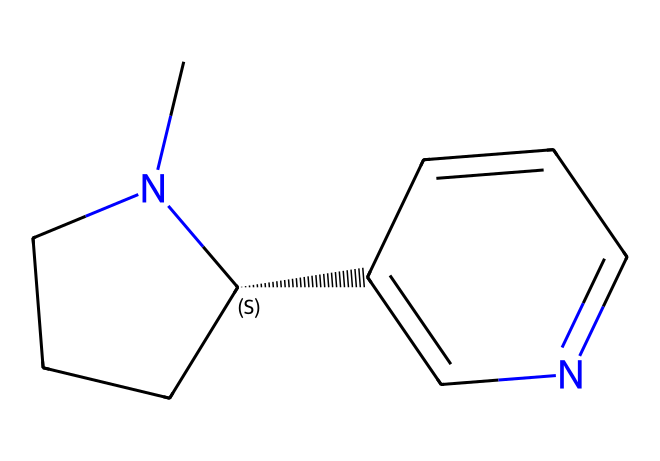What is the molecular formula of nicotine? To determine the molecular formula from the SMILES representation, we need to count the number of each type of atom present in the structure. The provided SMILES indicates there are 10 carbon atoms (C), 14 hydrogen atoms (H), and 2 nitrogen atoms (N). Therefore, the molecular formula is derived from this count.
Answer: C10H14N2 How many rings are present in the structure of nicotine? By analyzing the structure indicated by the SMILES notation, we can identify the presence of cyclic structures. The SMILES shows two distinct ring systems in the molecule. Therefore, we conclude that there are two rings.
Answer: 2 What functional groups can be identified in nicotine? The SMILES structure reveals specific atoms and bonding arrangements that form functional groups. In nicotine, we can identify nitrogen atoms, indicating the presence of amine functional groups contributing to its properties.
Answer: amine Which nitrogen atom is quaternary in the nicotine structure? In the given SMILES, the quaternary nitrogen is indicated by the carbon it’s attached to having four total substituents - this is the nitrogen in the cyclic structure connected to three carbons. Thus, we can identify that nitrogen atom as the quaternary atom.
Answer: nitrogen in ring How does nicotine's structure relate to its physiological effects? To understand how nicotine's structure contributes to its effects, we observe its ability to interact with nicotine receptors in the nervous system, which is influenced by its nitrogen atoms and branching structure. This interaction explains its stimulating and addictive properties.
Answer: interacts with receptors Is nicotine a stimulant or depressant? We can deduce nicotine's classification by considering its effects on the central nervous system. Nicotine is known to increase alertness and heart rate, categorizing it as a stimulant rather than a depressant.
Answer: stimulant 